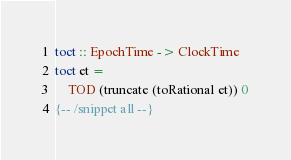Convert code to text. <code><loc_0><loc_0><loc_500><loc_500><_Haskell_>toct :: EpochTime -> ClockTime
toct et = 
    TOD (truncate (toRational et)) 0
{-- /snippet all --}
</code> 